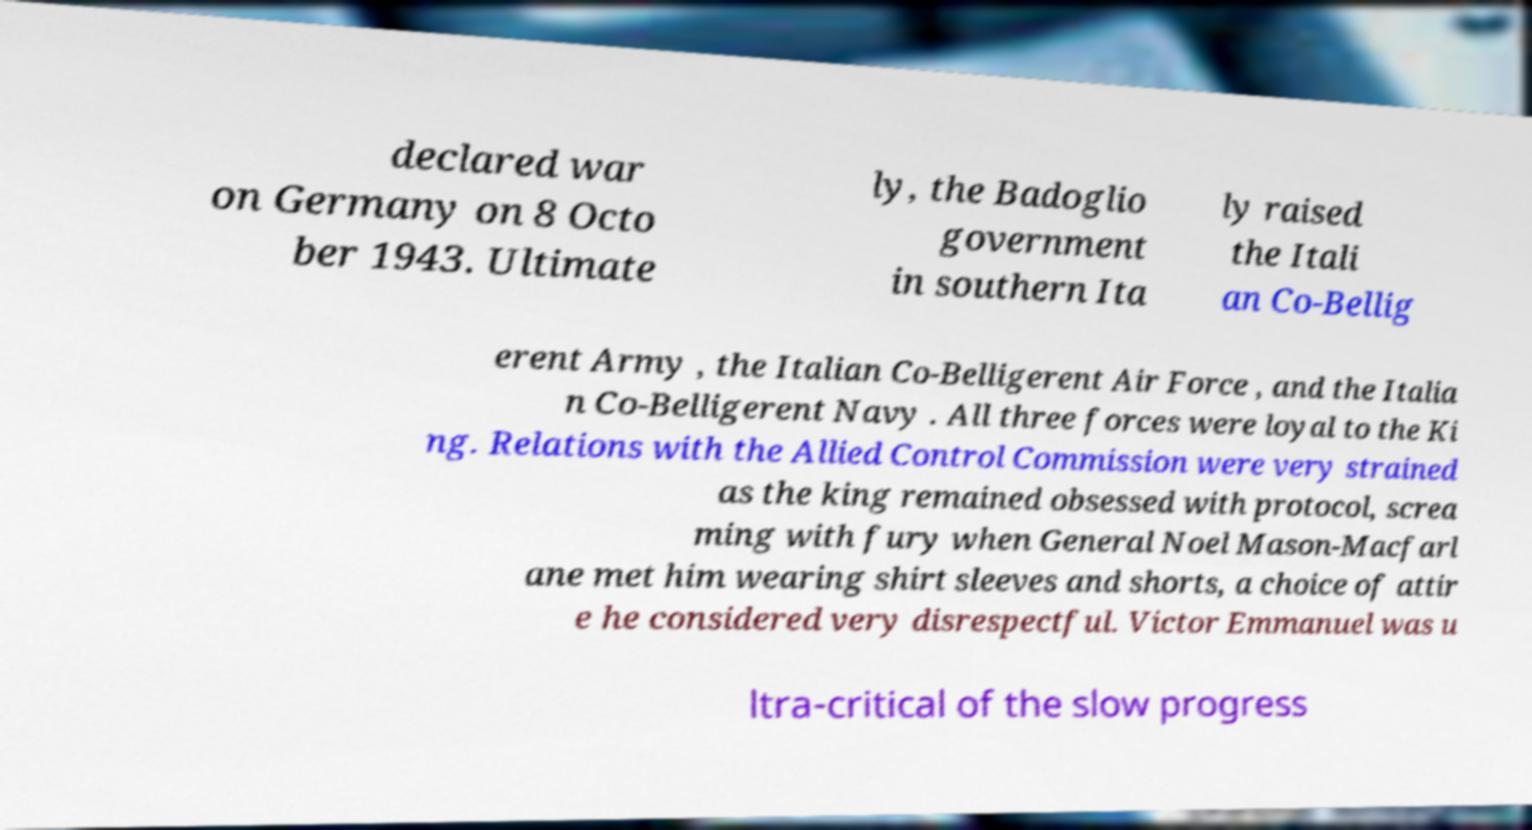There's text embedded in this image that I need extracted. Can you transcribe it verbatim? declared war on Germany on 8 Octo ber 1943. Ultimate ly, the Badoglio government in southern Ita ly raised the Itali an Co-Bellig erent Army , the Italian Co-Belligerent Air Force , and the Italia n Co-Belligerent Navy . All three forces were loyal to the Ki ng. Relations with the Allied Control Commission were very strained as the king remained obsessed with protocol, screa ming with fury when General Noel Mason-Macfarl ane met him wearing shirt sleeves and shorts, a choice of attir e he considered very disrespectful. Victor Emmanuel was u ltra-critical of the slow progress 